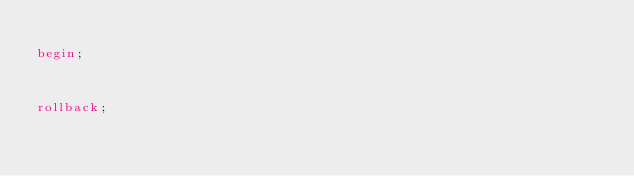<code> <loc_0><loc_0><loc_500><loc_500><_SQL_>
begin;



rollback;
</code> 